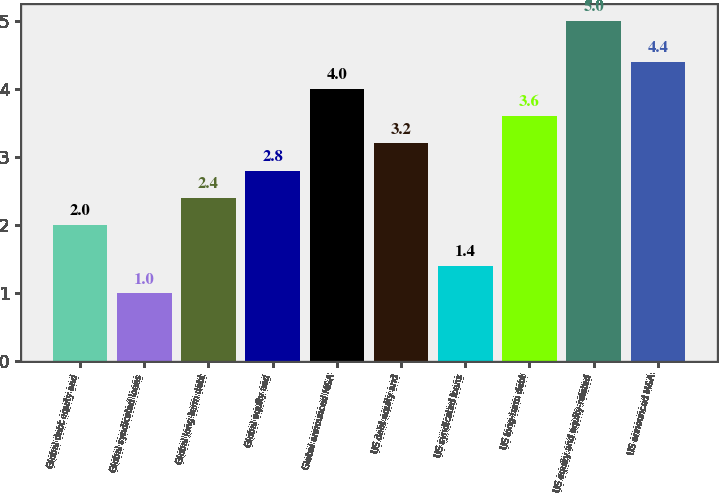Convert chart to OTSL. <chart><loc_0><loc_0><loc_500><loc_500><bar_chart><fcel>Global debt equity and<fcel>Global syndicated loans<fcel>Global long-term debt<fcel>Global equity and<fcel>Global announced M&A<fcel>US debt equity and<fcel>US syndicated loans<fcel>US long-term debt<fcel>US equity and equity-related<fcel>US announced M&A<nl><fcel>2<fcel>1<fcel>2.4<fcel>2.8<fcel>4<fcel>3.2<fcel>1.4<fcel>3.6<fcel>5<fcel>4.4<nl></chart> 